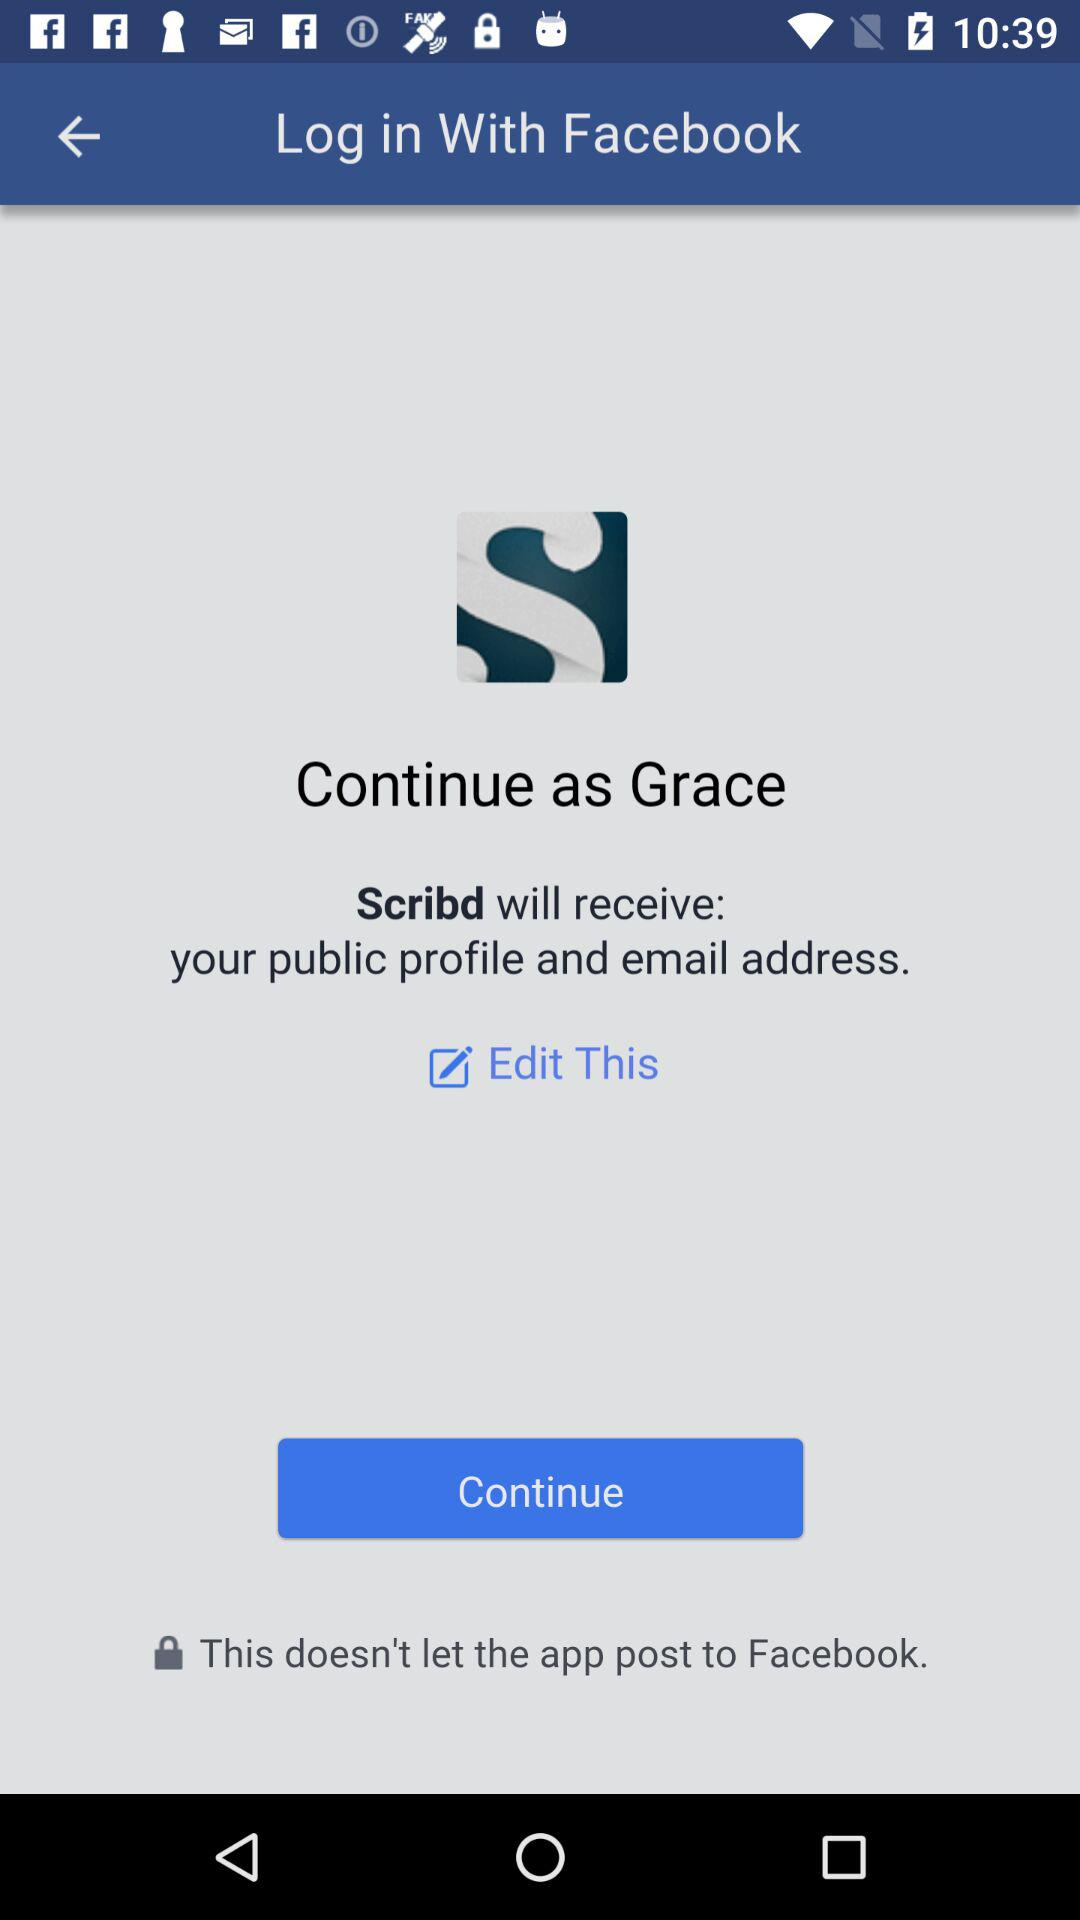Who will receive the public profile and email address? The public profile and email address will be received by "Scribd". 